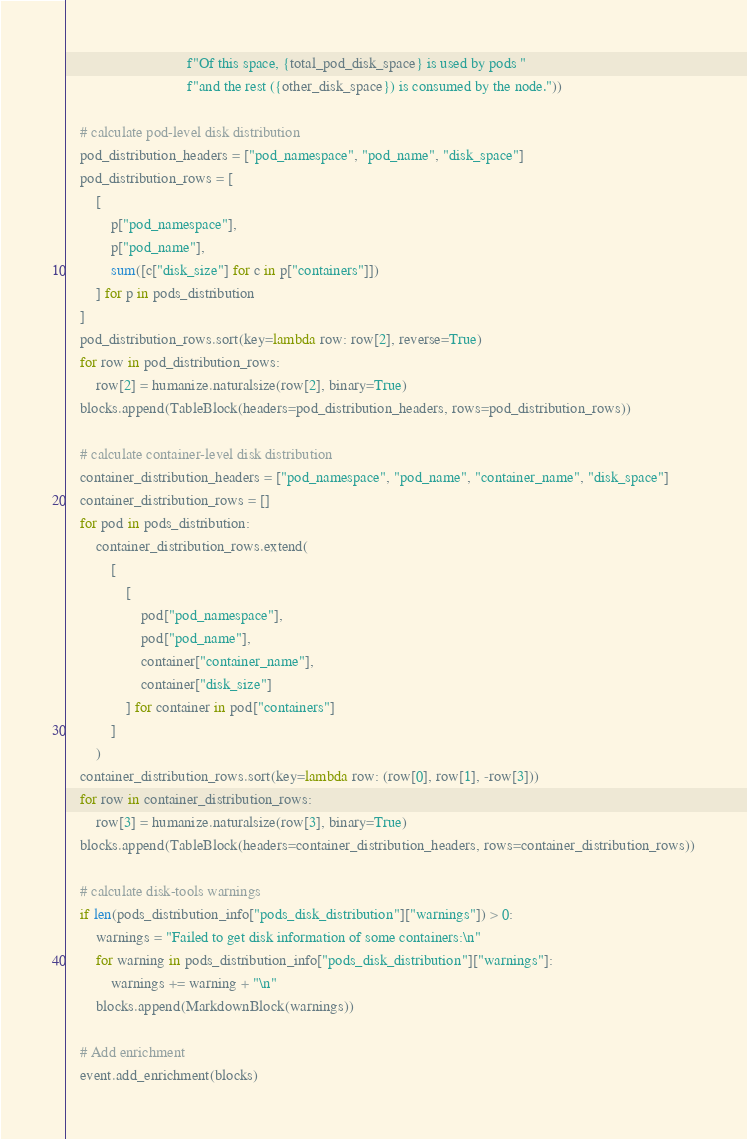<code> <loc_0><loc_0><loc_500><loc_500><_Python_>                                f"Of this space, {total_pod_disk_space} is used by pods "
                                f"and the rest ({other_disk_space}) is consumed by the node."))

    # calculate pod-level disk distribution
    pod_distribution_headers = ["pod_namespace", "pod_name", "disk_space"]
    pod_distribution_rows = [
        [
            p["pod_namespace"],
            p["pod_name"],
            sum([c["disk_size"] for c in p["containers"]])
        ] for p in pods_distribution
    ]
    pod_distribution_rows.sort(key=lambda row: row[2], reverse=True)
    for row in pod_distribution_rows:
        row[2] = humanize.naturalsize(row[2], binary=True)
    blocks.append(TableBlock(headers=pod_distribution_headers, rows=pod_distribution_rows))

    # calculate container-level disk distribution
    container_distribution_headers = ["pod_namespace", "pod_name", "container_name", "disk_space"]
    container_distribution_rows = []
    for pod in pods_distribution:
        container_distribution_rows.extend(
            [
                [
                    pod["pod_namespace"],
                    pod["pod_name"],
                    container["container_name"],
                    container["disk_size"]
                ] for container in pod["containers"]
            ]
        )
    container_distribution_rows.sort(key=lambda row: (row[0], row[1], -row[3]))
    for row in container_distribution_rows:
        row[3] = humanize.naturalsize(row[3], binary=True)
    blocks.append(TableBlock(headers=container_distribution_headers, rows=container_distribution_rows))

    # calculate disk-tools warnings
    if len(pods_distribution_info["pods_disk_distribution"]["warnings"]) > 0:
        warnings = "Failed to get disk information of some containers:\n"
        for warning in pods_distribution_info["pods_disk_distribution"]["warnings"]:
            warnings += warning + "\n"
        blocks.append(MarkdownBlock(warnings))

    # Add enrichment
    event.add_enrichment(blocks)
</code> 